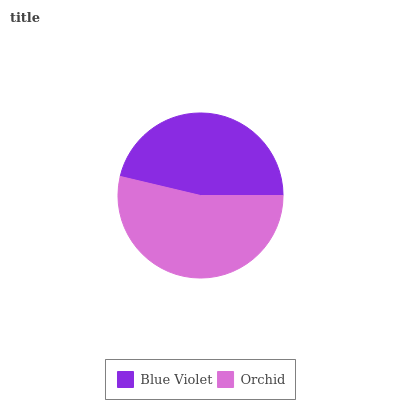Is Blue Violet the minimum?
Answer yes or no. Yes. Is Orchid the maximum?
Answer yes or no. Yes. Is Orchid the minimum?
Answer yes or no. No. Is Orchid greater than Blue Violet?
Answer yes or no. Yes. Is Blue Violet less than Orchid?
Answer yes or no. Yes. Is Blue Violet greater than Orchid?
Answer yes or no. No. Is Orchid less than Blue Violet?
Answer yes or no. No. Is Orchid the high median?
Answer yes or no. Yes. Is Blue Violet the low median?
Answer yes or no. Yes. Is Blue Violet the high median?
Answer yes or no. No. Is Orchid the low median?
Answer yes or no. No. 